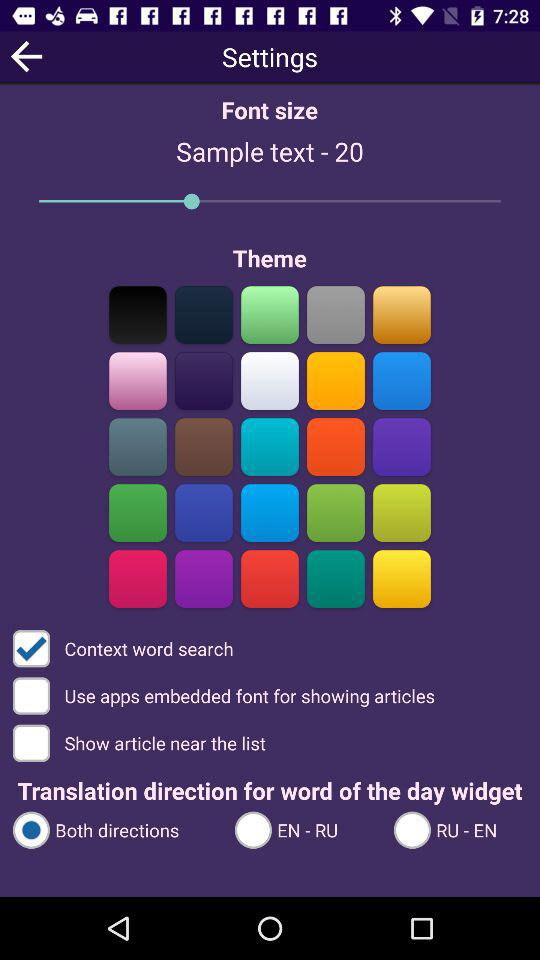What option is selected in "Translation direction for word of the day widget"? The selected option is "Both directions". 